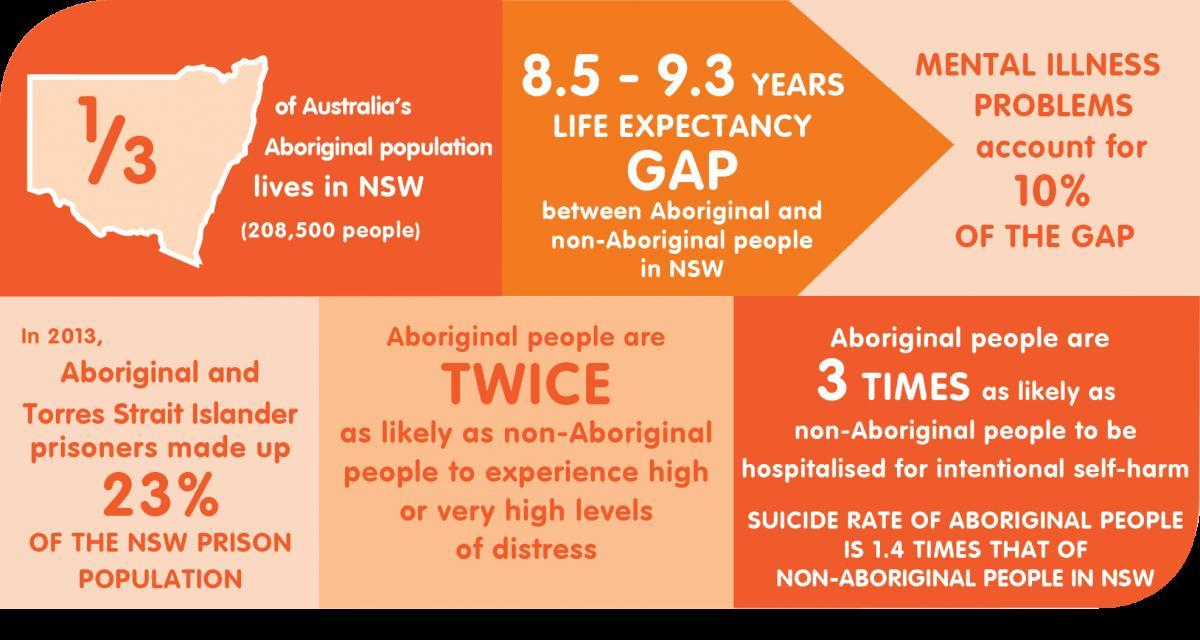What is the population size of australia's aboriginal people that lives in NSW?
Answer the question with a short phrase. 208,500 people What percentage of the NSW prison population accounts for the aboriginal & torres strait islander in 2013? 23% What is the life expectancy GAP between aboriginal & non-aboriginal people in NSW? 8.5 - 9.3 YEARS 